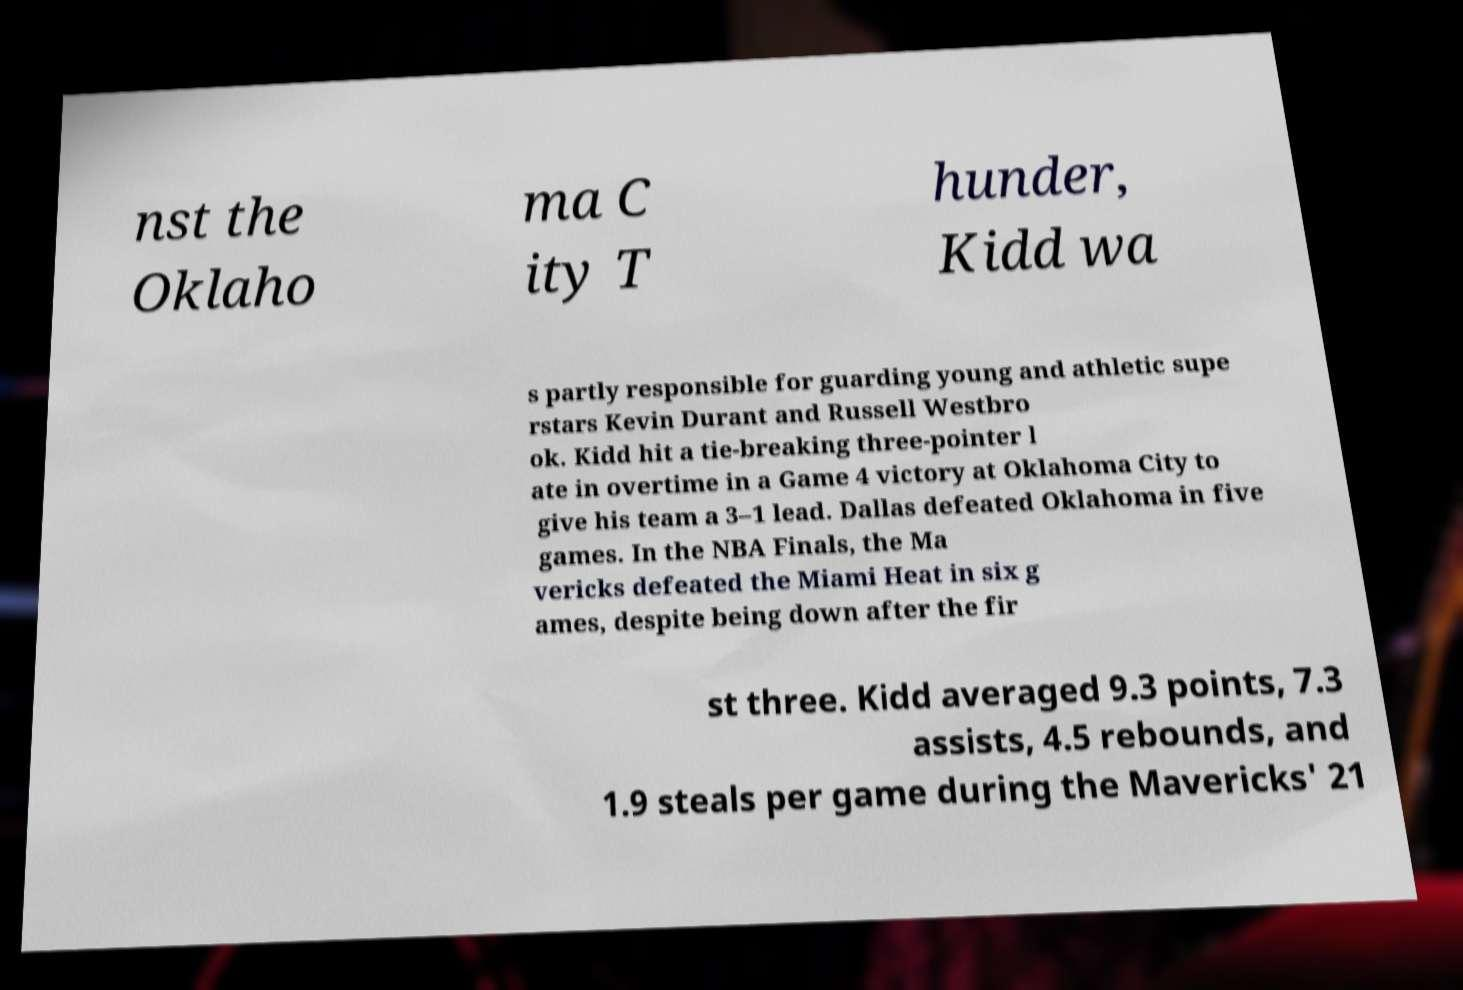Can you read and provide the text displayed in the image?This photo seems to have some interesting text. Can you extract and type it out for me? nst the Oklaho ma C ity T hunder, Kidd wa s partly responsible for guarding young and athletic supe rstars Kevin Durant and Russell Westbro ok. Kidd hit a tie-breaking three-pointer l ate in overtime in a Game 4 victory at Oklahoma City to give his team a 3–1 lead. Dallas defeated Oklahoma in five games. In the NBA Finals, the Ma vericks defeated the Miami Heat in six g ames, despite being down after the fir st three. Kidd averaged 9.3 points, 7.3 assists, 4.5 rebounds, and 1.9 steals per game during the Mavericks' 21 